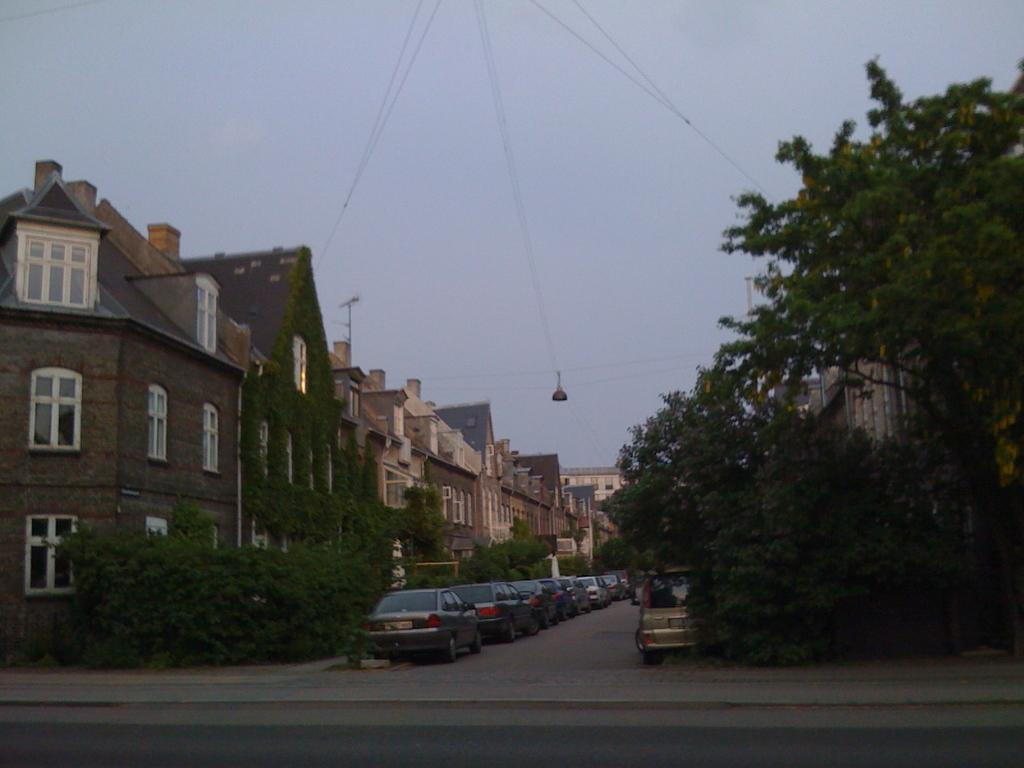What types of objects are present in the image? There are vehicles, trees, buildings, and the sky visible in the image. Can you describe the trees in the image? The trees are green and present on both the left and right sides of the image. How are the buildings in the image colored? The buildings are in cream and brown colors. What color is the sky in the image? The sky is in a white color. Where is the hall located in the image? There is no hall present in the image. What happens to the middle of the image when you crush it? The image cannot be crushed, as it is a two-dimensional representation. 